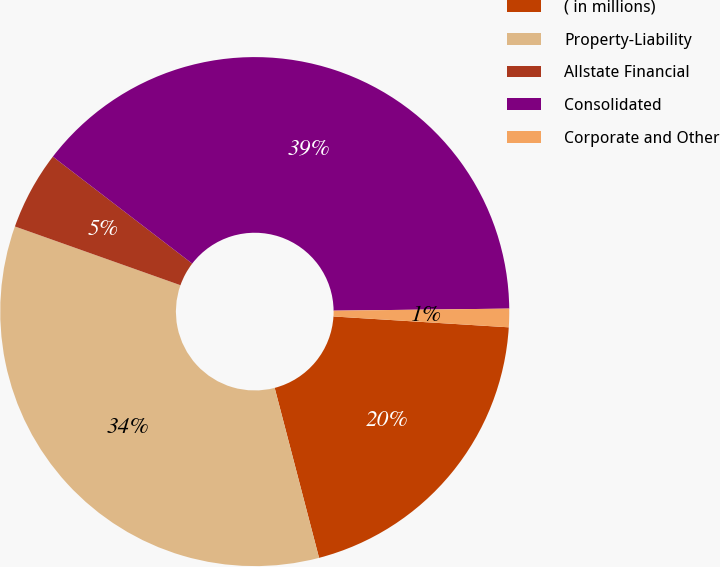Convert chart. <chart><loc_0><loc_0><loc_500><loc_500><pie_chart><fcel>( in millions)<fcel>Property-Liability<fcel>Allstate Financial<fcel>Consolidated<fcel>Corporate and Other<nl><fcel>19.95%<fcel>34.49%<fcel>4.99%<fcel>39.39%<fcel>1.17%<nl></chart> 